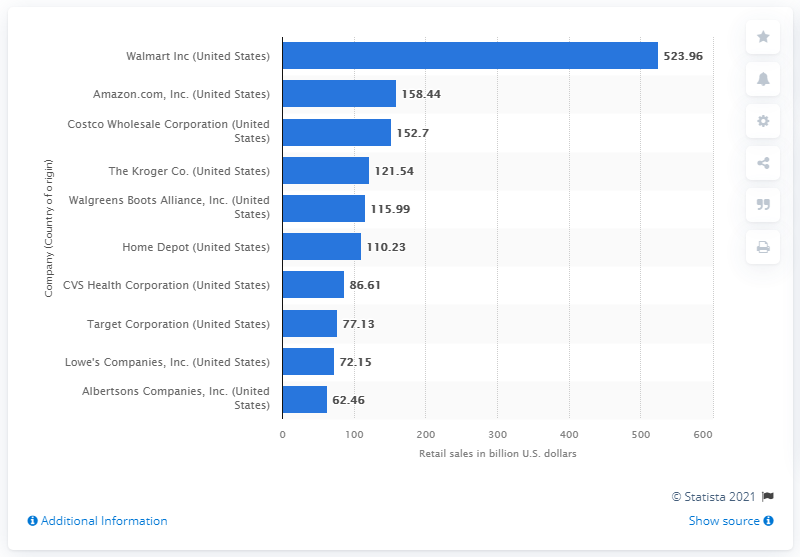Highlight a few significant elements in this photo. Walmart's retail sales in dollars in 2019 were approximately 523.96 billion U.S. dollars. Amazon generated sales revenue of 158.44 billion U.S. dollars in 2019. 